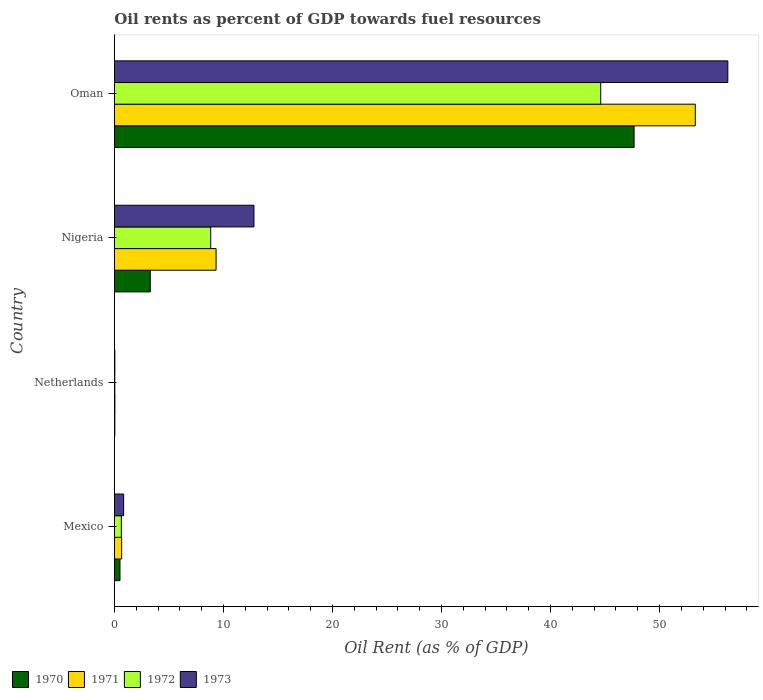How many different coloured bars are there?
Provide a short and direct response. 4. Are the number of bars per tick equal to the number of legend labels?
Provide a short and direct response. Yes. How many bars are there on the 3rd tick from the bottom?
Your response must be concise. 4. In how many cases, is the number of bars for a given country not equal to the number of legend labels?
Offer a terse response. 0. What is the oil rent in 1971 in Mexico?
Keep it short and to the point. 0.66. Across all countries, what is the maximum oil rent in 1971?
Offer a terse response. 53.28. Across all countries, what is the minimum oil rent in 1972?
Your response must be concise. 0.03. In which country was the oil rent in 1973 maximum?
Keep it short and to the point. Oman. In which country was the oil rent in 1970 minimum?
Offer a very short reply. Netherlands. What is the total oil rent in 1972 in the graph?
Provide a succinct answer. 54.1. What is the difference between the oil rent in 1971 in Mexico and that in Oman?
Make the answer very short. -52.61. What is the difference between the oil rent in 1970 in Nigeria and the oil rent in 1972 in Oman?
Your answer should be compact. -41.31. What is the average oil rent in 1973 per country?
Offer a terse response. 17.49. What is the difference between the oil rent in 1970 and oil rent in 1971 in Oman?
Provide a succinct answer. -5.61. What is the ratio of the oil rent in 1973 in Mexico to that in Oman?
Keep it short and to the point. 0.02. What is the difference between the highest and the second highest oil rent in 1970?
Ensure brevity in your answer.  44.37. What is the difference between the highest and the lowest oil rent in 1972?
Ensure brevity in your answer.  44.57. In how many countries, is the oil rent in 1970 greater than the average oil rent in 1970 taken over all countries?
Keep it short and to the point. 1. Is it the case that in every country, the sum of the oil rent in 1971 and oil rent in 1970 is greater than the sum of oil rent in 1973 and oil rent in 1972?
Provide a succinct answer. No. What does the 4th bar from the top in Mexico represents?
Offer a terse response. 1970. What does the 4th bar from the bottom in Mexico represents?
Keep it short and to the point. 1973. Is it the case that in every country, the sum of the oil rent in 1972 and oil rent in 1973 is greater than the oil rent in 1971?
Your response must be concise. Yes. Are all the bars in the graph horizontal?
Your response must be concise. Yes. How many countries are there in the graph?
Keep it short and to the point. 4. Are the values on the major ticks of X-axis written in scientific E-notation?
Provide a short and direct response. No. Does the graph contain any zero values?
Provide a short and direct response. No. Where does the legend appear in the graph?
Your answer should be very brief. Bottom left. How are the legend labels stacked?
Offer a very short reply. Horizontal. What is the title of the graph?
Offer a terse response. Oil rents as percent of GDP towards fuel resources. Does "1966" appear as one of the legend labels in the graph?
Your response must be concise. No. What is the label or title of the X-axis?
Provide a succinct answer. Oil Rent (as % of GDP). What is the label or title of the Y-axis?
Provide a succinct answer. Country. What is the Oil Rent (as % of GDP) of 1970 in Mexico?
Make the answer very short. 0.51. What is the Oil Rent (as % of GDP) in 1971 in Mexico?
Give a very brief answer. 0.66. What is the Oil Rent (as % of GDP) in 1972 in Mexico?
Keep it short and to the point. 0.63. What is the Oil Rent (as % of GDP) in 1973 in Mexico?
Offer a terse response. 0.84. What is the Oil Rent (as % of GDP) in 1970 in Netherlands?
Provide a short and direct response. 0.04. What is the Oil Rent (as % of GDP) of 1971 in Netherlands?
Your answer should be compact. 0.04. What is the Oil Rent (as % of GDP) in 1972 in Netherlands?
Keep it short and to the point. 0.03. What is the Oil Rent (as % of GDP) of 1973 in Netherlands?
Make the answer very short. 0.04. What is the Oil Rent (as % of GDP) in 1970 in Nigeria?
Keep it short and to the point. 3.29. What is the Oil Rent (as % of GDP) in 1971 in Nigeria?
Give a very brief answer. 9.32. What is the Oil Rent (as % of GDP) in 1972 in Nigeria?
Your answer should be very brief. 8.83. What is the Oil Rent (as % of GDP) of 1973 in Nigeria?
Keep it short and to the point. 12.8. What is the Oil Rent (as % of GDP) in 1970 in Oman?
Ensure brevity in your answer.  47.66. What is the Oil Rent (as % of GDP) of 1971 in Oman?
Give a very brief answer. 53.28. What is the Oil Rent (as % of GDP) in 1972 in Oman?
Your response must be concise. 44.6. What is the Oil Rent (as % of GDP) of 1973 in Oman?
Give a very brief answer. 56.26. Across all countries, what is the maximum Oil Rent (as % of GDP) in 1970?
Provide a succinct answer. 47.66. Across all countries, what is the maximum Oil Rent (as % of GDP) of 1971?
Your answer should be compact. 53.28. Across all countries, what is the maximum Oil Rent (as % of GDP) of 1972?
Make the answer very short. 44.6. Across all countries, what is the maximum Oil Rent (as % of GDP) in 1973?
Provide a succinct answer. 56.26. Across all countries, what is the minimum Oil Rent (as % of GDP) in 1970?
Ensure brevity in your answer.  0.04. Across all countries, what is the minimum Oil Rent (as % of GDP) in 1971?
Give a very brief answer. 0.04. Across all countries, what is the minimum Oil Rent (as % of GDP) of 1972?
Keep it short and to the point. 0.03. Across all countries, what is the minimum Oil Rent (as % of GDP) of 1973?
Give a very brief answer. 0.04. What is the total Oil Rent (as % of GDP) in 1970 in the graph?
Offer a very short reply. 51.5. What is the total Oil Rent (as % of GDP) of 1971 in the graph?
Your response must be concise. 63.31. What is the total Oil Rent (as % of GDP) of 1972 in the graph?
Ensure brevity in your answer.  54.1. What is the total Oil Rent (as % of GDP) in 1973 in the graph?
Ensure brevity in your answer.  69.94. What is the difference between the Oil Rent (as % of GDP) of 1970 in Mexico and that in Netherlands?
Provide a short and direct response. 0.47. What is the difference between the Oil Rent (as % of GDP) in 1971 in Mexico and that in Netherlands?
Offer a very short reply. 0.62. What is the difference between the Oil Rent (as % of GDP) in 1972 in Mexico and that in Netherlands?
Your response must be concise. 0.6. What is the difference between the Oil Rent (as % of GDP) in 1973 in Mexico and that in Netherlands?
Ensure brevity in your answer.  0.81. What is the difference between the Oil Rent (as % of GDP) of 1970 in Mexico and that in Nigeria?
Your response must be concise. -2.78. What is the difference between the Oil Rent (as % of GDP) in 1971 in Mexico and that in Nigeria?
Provide a succinct answer. -8.66. What is the difference between the Oil Rent (as % of GDP) of 1972 in Mexico and that in Nigeria?
Provide a short and direct response. -8.19. What is the difference between the Oil Rent (as % of GDP) of 1973 in Mexico and that in Nigeria?
Provide a succinct answer. -11.95. What is the difference between the Oil Rent (as % of GDP) of 1970 in Mexico and that in Oman?
Provide a succinct answer. -47.15. What is the difference between the Oil Rent (as % of GDP) in 1971 in Mexico and that in Oman?
Your answer should be very brief. -52.61. What is the difference between the Oil Rent (as % of GDP) of 1972 in Mexico and that in Oman?
Your answer should be compact. -43.97. What is the difference between the Oil Rent (as % of GDP) in 1973 in Mexico and that in Oman?
Give a very brief answer. -55.41. What is the difference between the Oil Rent (as % of GDP) in 1970 in Netherlands and that in Nigeria?
Your answer should be very brief. -3.25. What is the difference between the Oil Rent (as % of GDP) in 1971 in Netherlands and that in Nigeria?
Provide a short and direct response. -9.28. What is the difference between the Oil Rent (as % of GDP) in 1972 in Netherlands and that in Nigeria?
Offer a terse response. -8.79. What is the difference between the Oil Rent (as % of GDP) of 1973 in Netherlands and that in Nigeria?
Your answer should be very brief. -12.76. What is the difference between the Oil Rent (as % of GDP) of 1970 in Netherlands and that in Oman?
Offer a very short reply. -47.62. What is the difference between the Oil Rent (as % of GDP) of 1971 in Netherlands and that in Oman?
Your answer should be very brief. -53.23. What is the difference between the Oil Rent (as % of GDP) in 1972 in Netherlands and that in Oman?
Make the answer very short. -44.57. What is the difference between the Oil Rent (as % of GDP) in 1973 in Netherlands and that in Oman?
Offer a very short reply. -56.22. What is the difference between the Oil Rent (as % of GDP) of 1970 in Nigeria and that in Oman?
Make the answer very short. -44.37. What is the difference between the Oil Rent (as % of GDP) of 1971 in Nigeria and that in Oman?
Offer a very short reply. -43.95. What is the difference between the Oil Rent (as % of GDP) of 1972 in Nigeria and that in Oman?
Your answer should be compact. -35.77. What is the difference between the Oil Rent (as % of GDP) of 1973 in Nigeria and that in Oman?
Give a very brief answer. -43.46. What is the difference between the Oil Rent (as % of GDP) in 1970 in Mexico and the Oil Rent (as % of GDP) in 1971 in Netherlands?
Offer a very short reply. 0.47. What is the difference between the Oil Rent (as % of GDP) of 1970 in Mexico and the Oil Rent (as % of GDP) of 1972 in Netherlands?
Provide a short and direct response. 0.47. What is the difference between the Oil Rent (as % of GDP) of 1970 in Mexico and the Oil Rent (as % of GDP) of 1973 in Netherlands?
Your response must be concise. 0.47. What is the difference between the Oil Rent (as % of GDP) in 1971 in Mexico and the Oil Rent (as % of GDP) in 1972 in Netherlands?
Provide a succinct answer. 0.63. What is the difference between the Oil Rent (as % of GDP) of 1971 in Mexico and the Oil Rent (as % of GDP) of 1973 in Netherlands?
Your response must be concise. 0.62. What is the difference between the Oil Rent (as % of GDP) of 1972 in Mexico and the Oil Rent (as % of GDP) of 1973 in Netherlands?
Provide a short and direct response. 0.6. What is the difference between the Oil Rent (as % of GDP) in 1970 in Mexico and the Oil Rent (as % of GDP) in 1971 in Nigeria?
Provide a short and direct response. -8.81. What is the difference between the Oil Rent (as % of GDP) of 1970 in Mexico and the Oil Rent (as % of GDP) of 1972 in Nigeria?
Provide a short and direct response. -8.32. What is the difference between the Oil Rent (as % of GDP) of 1970 in Mexico and the Oil Rent (as % of GDP) of 1973 in Nigeria?
Keep it short and to the point. -12.29. What is the difference between the Oil Rent (as % of GDP) of 1971 in Mexico and the Oil Rent (as % of GDP) of 1972 in Nigeria?
Give a very brief answer. -8.17. What is the difference between the Oil Rent (as % of GDP) of 1971 in Mexico and the Oil Rent (as % of GDP) of 1973 in Nigeria?
Give a very brief answer. -12.14. What is the difference between the Oil Rent (as % of GDP) in 1972 in Mexico and the Oil Rent (as % of GDP) in 1973 in Nigeria?
Your answer should be compact. -12.16. What is the difference between the Oil Rent (as % of GDP) of 1970 in Mexico and the Oil Rent (as % of GDP) of 1971 in Oman?
Provide a succinct answer. -52.77. What is the difference between the Oil Rent (as % of GDP) in 1970 in Mexico and the Oil Rent (as % of GDP) in 1972 in Oman?
Ensure brevity in your answer.  -44.09. What is the difference between the Oil Rent (as % of GDP) in 1970 in Mexico and the Oil Rent (as % of GDP) in 1973 in Oman?
Your answer should be very brief. -55.75. What is the difference between the Oil Rent (as % of GDP) of 1971 in Mexico and the Oil Rent (as % of GDP) of 1972 in Oman?
Provide a succinct answer. -43.94. What is the difference between the Oil Rent (as % of GDP) of 1971 in Mexico and the Oil Rent (as % of GDP) of 1973 in Oman?
Ensure brevity in your answer.  -55.6. What is the difference between the Oil Rent (as % of GDP) of 1972 in Mexico and the Oil Rent (as % of GDP) of 1973 in Oman?
Provide a succinct answer. -55.62. What is the difference between the Oil Rent (as % of GDP) in 1970 in Netherlands and the Oil Rent (as % of GDP) in 1971 in Nigeria?
Your answer should be compact. -9.29. What is the difference between the Oil Rent (as % of GDP) of 1970 in Netherlands and the Oil Rent (as % of GDP) of 1972 in Nigeria?
Your answer should be very brief. -8.79. What is the difference between the Oil Rent (as % of GDP) in 1970 in Netherlands and the Oil Rent (as % of GDP) in 1973 in Nigeria?
Your response must be concise. -12.76. What is the difference between the Oil Rent (as % of GDP) in 1971 in Netherlands and the Oil Rent (as % of GDP) in 1972 in Nigeria?
Provide a short and direct response. -8.79. What is the difference between the Oil Rent (as % of GDP) of 1971 in Netherlands and the Oil Rent (as % of GDP) of 1973 in Nigeria?
Provide a succinct answer. -12.76. What is the difference between the Oil Rent (as % of GDP) in 1972 in Netherlands and the Oil Rent (as % of GDP) in 1973 in Nigeria?
Your answer should be compact. -12.76. What is the difference between the Oil Rent (as % of GDP) of 1970 in Netherlands and the Oil Rent (as % of GDP) of 1971 in Oman?
Provide a short and direct response. -53.24. What is the difference between the Oil Rent (as % of GDP) of 1970 in Netherlands and the Oil Rent (as % of GDP) of 1972 in Oman?
Make the answer very short. -44.56. What is the difference between the Oil Rent (as % of GDP) in 1970 in Netherlands and the Oil Rent (as % of GDP) in 1973 in Oman?
Make the answer very short. -56.22. What is the difference between the Oil Rent (as % of GDP) of 1971 in Netherlands and the Oil Rent (as % of GDP) of 1972 in Oman?
Give a very brief answer. -44.56. What is the difference between the Oil Rent (as % of GDP) of 1971 in Netherlands and the Oil Rent (as % of GDP) of 1973 in Oman?
Your answer should be compact. -56.22. What is the difference between the Oil Rent (as % of GDP) in 1972 in Netherlands and the Oil Rent (as % of GDP) in 1973 in Oman?
Make the answer very short. -56.22. What is the difference between the Oil Rent (as % of GDP) in 1970 in Nigeria and the Oil Rent (as % of GDP) in 1971 in Oman?
Your answer should be very brief. -49.99. What is the difference between the Oil Rent (as % of GDP) in 1970 in Nigeria and the Oil Rent (as % of GDP) in 1972 in Oman?
Provide a succinct answer. -41.31. What is the difference between the Oil Rent (as % of GDP) in 1970 in Nigeria and the Oil Rent (as % of GDP) in 1973 in Oman?
Provide a succinct answer. -52.97. What is the difference between the Oil Rent (as % of GDP) in 1971 in Nigeria and the Oil Rent (as % of GDP) in 1972 in Oman?
Offer a terse response. -35.28. What is the difference between the Oil Rent (as % of GDP) in 1971 in Nigeria and the Oil Rent (as % of GDP) in 1973 in Oman?
Offer a very short reply. -46.94. What is the difference between the Oil Rent (as % of GDP) in 1972 in Nigeria and the Oil Rent (as % of GDP) in 1973 in Oman?
Keep it short and to the point. -47.43. What is the average Oil Rent (as % of GDP) in 1970 per country?
Your answer should be very brief. 12.87. What is the average Oil Rent (as % of GDP) in 1971 per country?
Provide a succinct answer. 15.83. What is the average Oil Rent (as % of GDP) in 1972 per country?
Offer a terse response. 13.52. What is the average Oil Rent (as % of GDP) of 1973 per country?
Ensure brevity in your answer.  17.49. What is the difference between the Oil Rent (as % of GDP) in 1970 and Oil Rent (as % of GDP) in 1971 in Mexico?
Give a very brief answer. -0.15. What is the difference between the Oil Rent (as % of GDP) in 1970 and Oil Rent (as % of GDP) in 1972 in Mexico?
Offer a terse response. -0.13. What is the difference between the Oil Rent (as % of GDP) in 1970 and Oil Rent (as % of GDP) in 1973 in Mexico?
Provide a short and direct response. -0.34. What is the difference between the Oil Rent (as % of GDP) in 1971 and Oil Rent (as % of GDP) in 1972 in Mexico?
Offer a terse response. 0.03. What is the difference between the Oil Rent (as % of GDP) of 1971 and Oil Rent (as % of GDP) of 1973 in Mexico?
Ensure brevity in your answer.  -0.18. What is the difference between the Oil Rent (as % of GDP) in 1972 and Oil Rent (as % of GDP) in 1973 in Mexico?
Give a very brief answer. -0.21. What is the difference between the Oil Rent (as % of GDP) of 1970 and Oil Rent (as % of GDP) of 1971 in Netherlands?
Give a very brief answer. -0.01. What is the difference between the Oil Rent (as % of GDP) in 1970 and Oil Rent (as % of GDP) in 1972 in Netherlands?
Your answer should be very brief. 0. What is the difference between the Oil Rent (as % of GDP) in 1970 and Oil Rent (as % of GDP) in 1973 in Netherlands?
Offer a very short reply. -0. What is the difference between the Oil Rent (as % of GDP) in 1971 and Oil Rent (as % of GDP) in 1972 in Netherlands?
Ensure brevity in your answer.  0.01. What is the difference between the Oil Rent (as % of GDP) of 1971 and Oil Rent (as % of GDP) of 1973 in Netherlands?
Give a very brief answer. 0. What is the difference between the Oil Rent (as % of GDP) of 1972 and Oil Rent (as % of GDP) of 1973 in Netherlands?
Offer a terse response. -0. What is the difference between the Oil Rent (as % of GDP) in 1970 and Oil Rent (as % of GDP) in 1971 in Nigeria?
Ensure brevity in your answer.  -6.03. What is the difference between the Oil Rent (as % of GDP) of 1970 and Oil Rent (as % of GDP) of 1972 in Nigeria?
Your answer should be very brief. -5.54. What is the difference between the Oil Rent (as % of GDP) of 1970 and Oil Rent (as % of GDP) of 1973 in Nigeria?
Your response must be concise. -9.51. What is the difference between the Oil Rent (as % of GDP) of 1971 and Oil Rent (as % of GDP) of 1972 in Nigeria?
Keep it short and to the point. 0.49. What is the difference between the Oil Rent (as % of GDP) of 1971 and Oil Rent (as % of GDP) of 1973 in Nigeria?
Your answer should be compact. -3.48. What is the difference between the Oil Rent (as % of GDP) of 1972 and Oil Rent (as % of GDP) of 1973 in Nigeria?
Your answer should be compact. -3.97. What is the difference between the Oil Rent (as % of GDP) of 1970 and Oil Rent (as % of GDP) of 1971 in Oman?
Provide a succinct answer. -5.61. What is the difference between the Oil Rent (as % of GDP) of 1970 and Oil Rent (as % of GDP) of 1972 in Oman?
Offer a terse response. 3.06. What is the difference between the Oil Rent (as % of GDP) of 1970 and Oil Rent (as % of GDP) of 1973 in Oman?
Your answer should be very brief. -8.6. What is the difference between the Oil Rent (as % of GDP) in 1971 and Oil Rent (as % of GDP) in 1972 in Oman?
Ensure brevity in your answer.  8.68. What is the difference between the Oil Rent (as % of GDP) in 1971 and Oil Rent (as % of GDP) in 1973 in Oman?
Your answer should be compact. -2.98. What is the difference between the Oil Rent (as % of GDP) in 1972 and Oil Rent (as % of GDP) in 1973 in Oman?
Ensure brevity in your answer.  -11.66. What is the ratio of the Oil Rent (as % of GDP) of 1970 in Mexico to that in Netherlands?
Make the answer very short. 13.43. What is the ratio of the Oil Rent (as % of GDP) in 1971 in Mexico to that in Netherlands?
Make the answer very short. 15.37. What is the ratio of the Oil Rent (as % of GDP) of 1972 in Mexico to that in Netherlands?
Your answer should be compact. 18.28. What is the ratio of the Oil Rent (as % of GDP) of 1973 in Mexico to that in Netherlands?
Your answer should be compact. 21.38. What is the ratio of the Oil Rent (as % of GDP) in 1970 in Mexico to that in Nigeria?
Give a very brief answer. 0.15. What is the ratio of the Oil Rent (as % of GDP) of 1971 in Mexico to that in Nigeria?
Your answer should be very brief. 0.07. What is the ratio of the Oil Rent (as % of GDP) of 1972 in Mexico to that in Nigeria?
Keep it short and to the point. 0.07. What is the ratio of the Oil Rent (as % of GDP) of 1973 in Mexico to that in Nigeria?
Offer a terse response. 0.07. What is the ratio of the Oil Rent (as % of GDP) in 1970 in Mexico to that in Oman?
Provide a short and direct response. 0.01. What is the ratio of the Oil Rent (as % of GDP) in 1971 in Mexico to that in Oman?
Make the answer very short. 0.01. What is the ratio of the Oil Rent (as % of GDP) in 1972 in Mexico to that in Oman?
Provide a succinct answer. 0.01. What is the ratio of the Oil Rent (as % of GDP) in 1973 in Mexico to that in Oman?
Your answer should be compact. 0.01. What is the ratio of the Oil Rent (as % of GDP) in 1970 in Netherlands to that in Nigeria?
Provide a succinct answer. 0.01. What is the ratio of the Oil Rent (as % of GDP) in 1971 in Netherlands to that in Nigeria?
Provide a short and direct response. 0. What is the ratio of the Oil Rent (as % of GDP) of 1972 in Netherlands to that in Nigeria?
Your response must be concise. 0. What is the ratio of the Oil Rent (as % of GDP) in 1973 in Netherlands to that in Nigeria?
Ensure brevity in your answer.  0. What is the ratio of the Oil Rent (as % of GDP) in 1970 in Netherlands to that in Oman?
Provide a short and direct response. 0. What is the ratio of the Oil Rent (as % of GDP) of 1971 in Netherlands to that in Oman?
Your answer should be compact. 0. What is the ratio of the Oil Rent (as % of GDP) in 1972 in Netherlands to that in Oman?
Your answer should be compact. 0. What is the ratio of the Oil Rent (as % of GDP) in 1973 in Netherlands to that in Oman?
Make the answer very short. 0. What is the ratio of the Oil Rent (as % of GDP) in 1970 in Nigeria to that in Oman?
Your answer should be compact. 0.07. What is the ratio of the Oil Rent (as % of GDP) of 1971 in Nigeria to that in Oman?
Offer a very short reply. 0.17. What is the ratio of the Oil Rent (as % of GDP) of 1972 in Nigeria to that in Oman?
Your answer should be compact. 0.2. What is the ratio of the Oil Rent (as % of GDP) of 1973 in Nigeria to that in Oman?
Your answer should be compact. 0.23. What is the difference between the highest and the second highest Oil Rent (as % of GDP) of 1970?
Offer a terse response. 44.37. What is the difference between the highest and the second highest Oil Rent (as % of GDP) in 1971?
Offer a very short reply. 43.95. What is the difference between the highest and the second highest Oil Rent (as % of GDP) of 1972?
Your response must be concise. 35.77. What is the difference between the highest and the second highest Oil Rent (as % of GDP) in 1973?
Offer a terse response. 43.46. What is the difference between the highest and the lowest Oil Rent (as % of GDP) of 1970?
Provide a succinct answer. 47.62. What is the difference between the highest and the lowest Oil Rent (as % of GDP) in 1971?
Your answer should be very brief. 53.23. What is the difference between the highest and the lowest Oil Rent (as % of GDP) of 1972?
Your answer should be compact. 44.57. What is the difference between the highest and the lowest Oil Rent (as % of GDP) in 1973?
Your response must be concise. 56.22. 